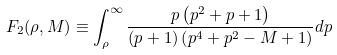<formula> <loc_0><loc_0><loc_500><loc_500>F _ { 2 } ( \rho , M ) \equiv \int _ { \rho } ^ { \infty } \frac { p \left ( p ^ { 2 } + p + 1 \right ) } { ( p + 1 ) \left ( p ^ { 4 } + p ^ { 2 } - M + 1 \right ) } d p</formula> 